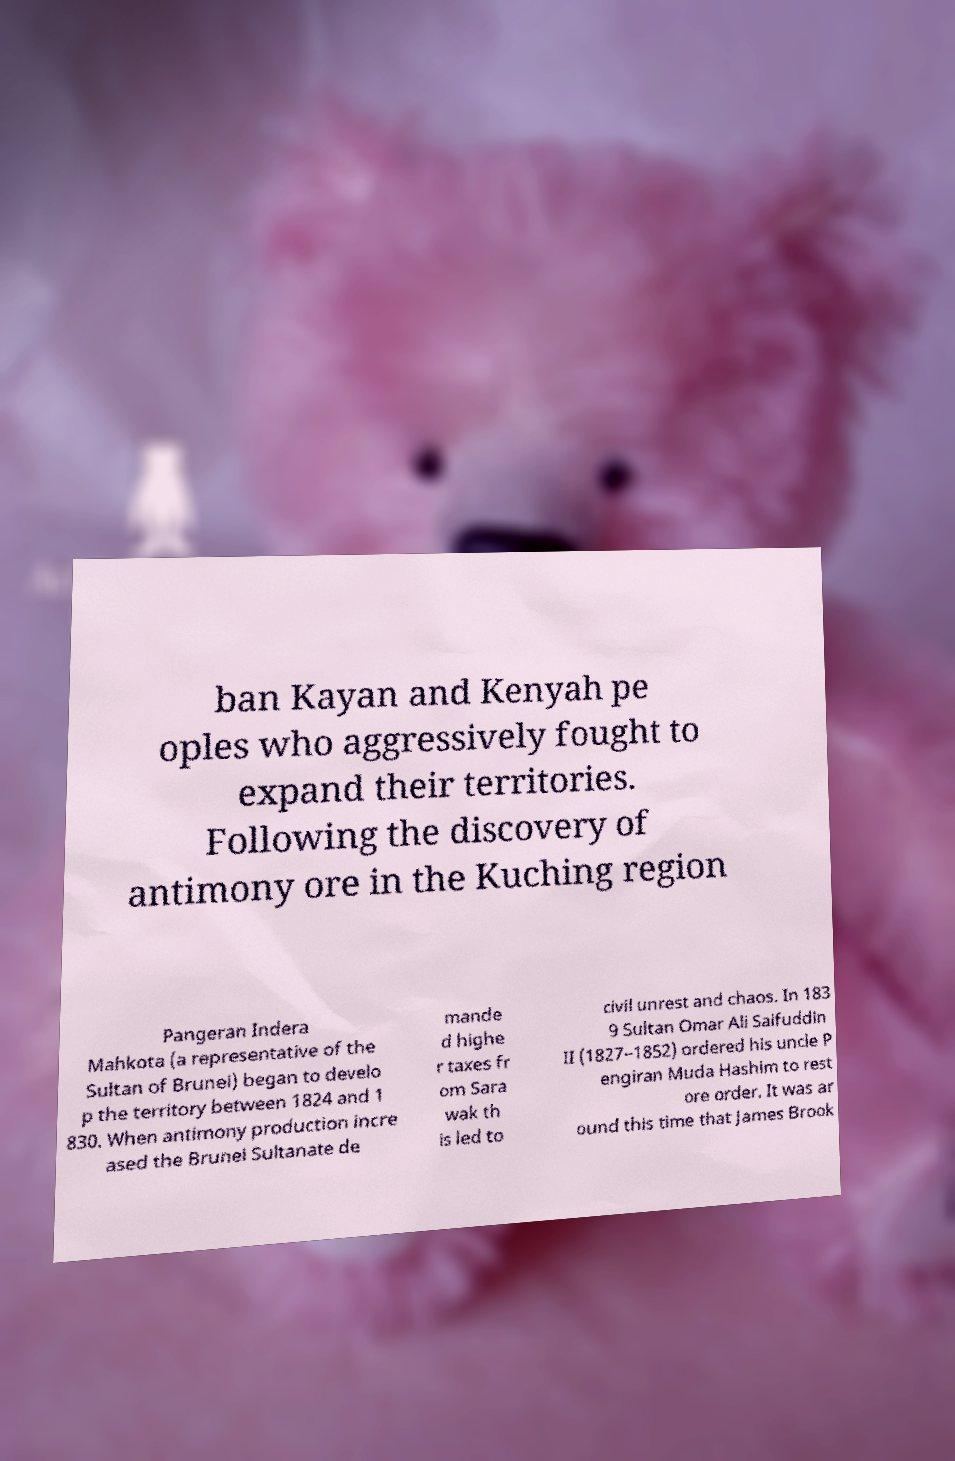For documentation purposes, I need the text within this image transcribed. Could you provide that? ban Kayan and Kenyah pe oples who aggressively fought to expand their territories. Following the discovery of antimony ore in the Kuching region Pangeran Indera Mahkota (a representative of the Sultan of Brunei) began to develo p the territory between 1824 and 1 830. When antimony production incre ased the Brunei Sultanate de mande d highe r taxes fr om Sara wak th is led to civil unrest and chaos. In 183 9 Sultan Omar Ali Saifuddin II (1827–1852) ordered his uncle P engiran Muda Hashim to rest ore order. It was ar ound this time that James Brook 